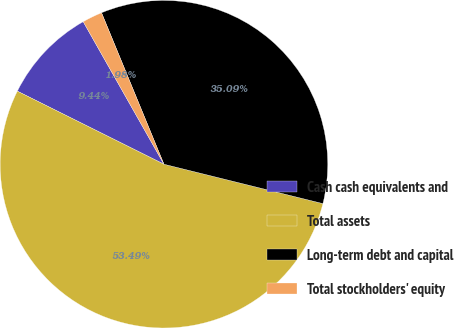Convert chart to OTSL. <chart><loc_0><loc_0><loc_500><loc_500><pie_chart><fcel>Cash cash equivalents and<fcel>Total assets<fcel>Long-term debt and capital<fcel>Total stockholders' equity<nl><fcel>9.44%<fcel>53.5%<fcel>35.09%<fcel>1.98%<nl></chart> 